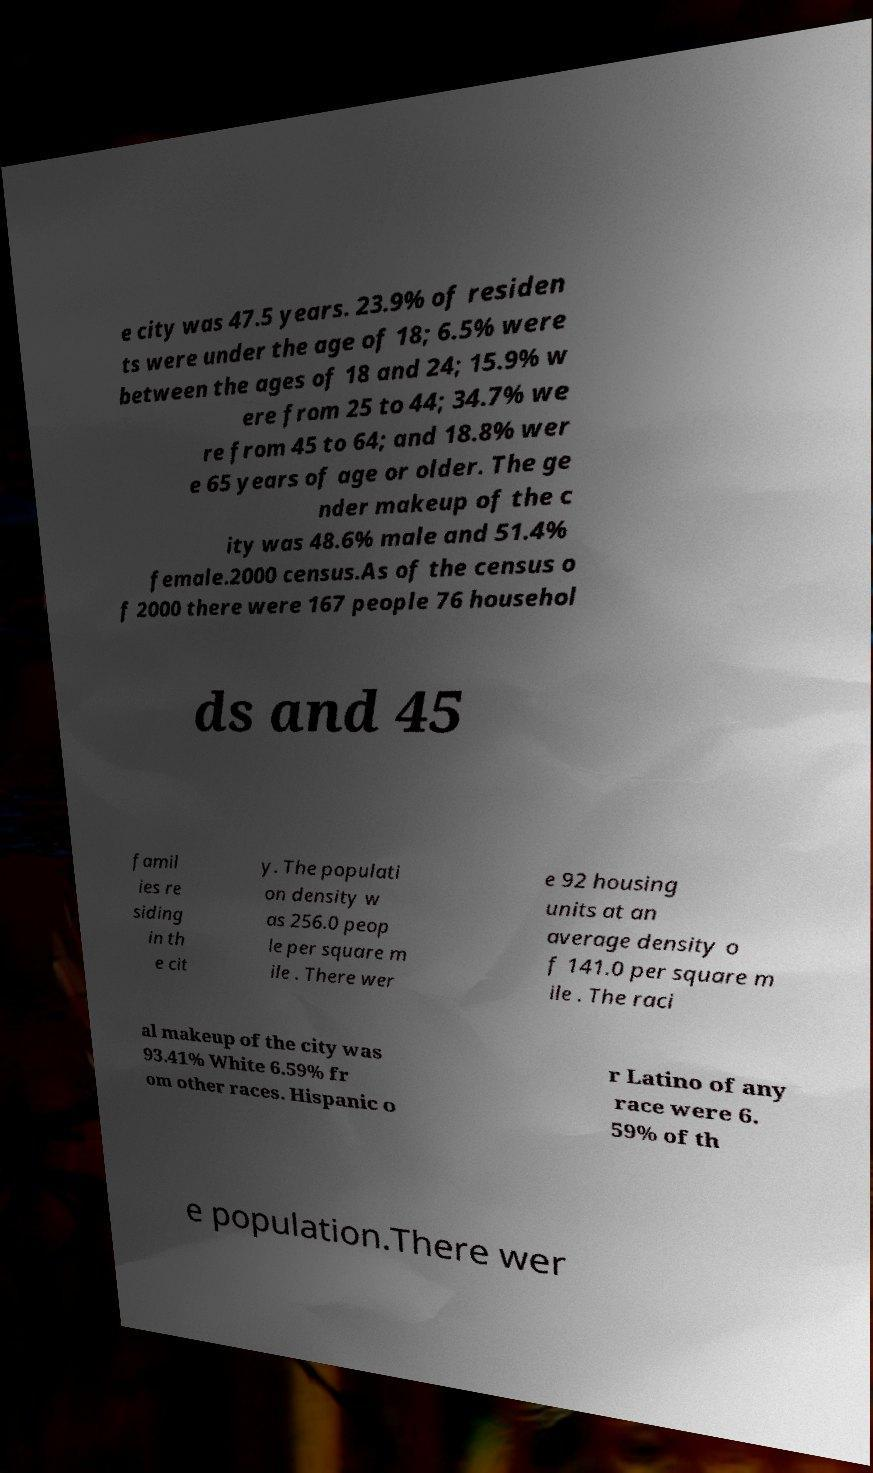Could you assist in decoding the text presented in this image and type it out clearly? e city was 47.5 years. 23.9% of residen ts were under the age of 18; 6.5% were between the ages of 18 and 24; 15.9% w ere from 25 to 44; 34.7% we re from 45 to 64; and 18.8% wer e 65 years of age or older. The ge nder makeup of the c ity was 48.6% male and 51.4% female.2000 census.As of the census o f 2000 there were 167 people 76 househol ds and 45 famil ies re siding in th e cit y. The populati on density w as 256.0 peop le per square m ile . There wer e 92 housing units at an average density o f 141.0 per square m ile . The raci al makeup of the city was 93.41% White 6.59% fr om other races. Hispanic o r Latino of any race were 6. 59% of th e population.There wer 